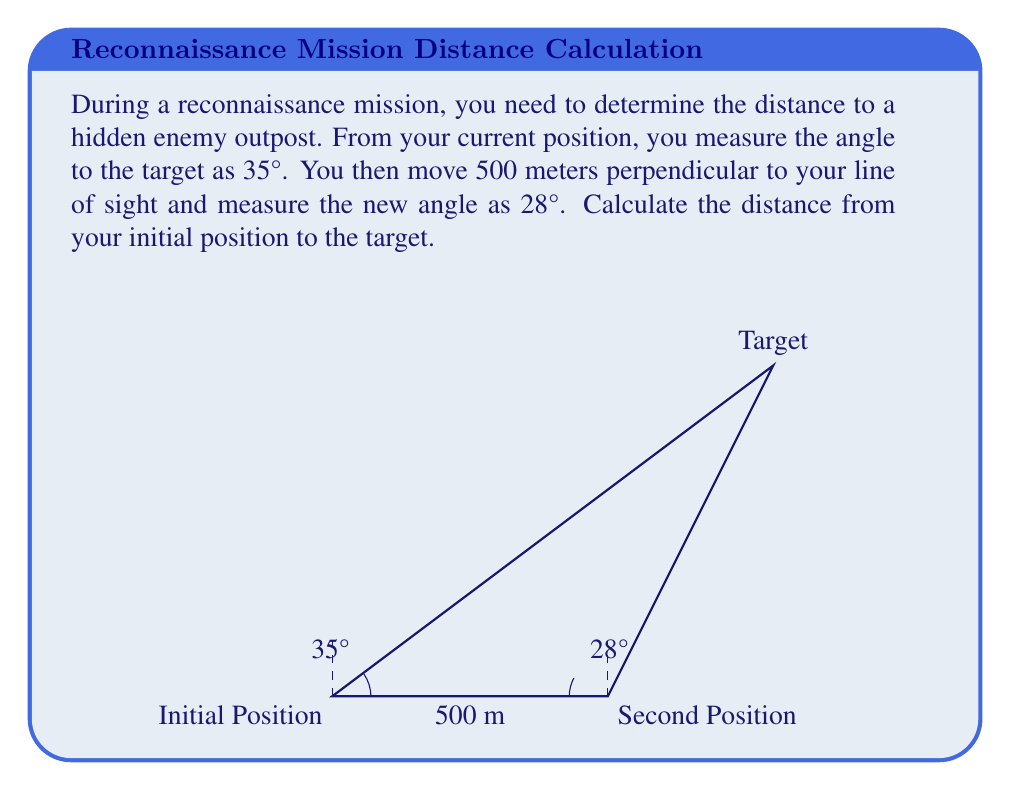What is the answer to this math problem? Let's solve this step-by-step using trigonometry:

1) First, we need to set up our triangle. Let's call the initial position A, the second position B, and the target C.

2) We know the distance AB = 500 meters, and the angles at A and B.

3) We can use the law of sines to solve this problem. The law of sines states:

   $$\frac{a}{\sin(A)} = \frac{b}{\sin(B)} = \frac{c}{\sin(C)}$$

   where a, b, and c are the lengths of the sides opposite to angles A, B, and C respectively.

4) In our case, we want to find AC (the distance to the target). Let's call this distance x. We know:
   - AB = 500 m
   - Angle at A = 35°
   - Angle at B = 28°

5) The angle at C is 180° - 35° - 28° = 117° (the sum of angles in a triangle is 180°)

6) Now we can set up our law of sines equation:

   $$\frac{x}{\sin(117°)} = \frac{500}{\sin(35°)}$$

7) Solving for x:

   $$x = \frac{500 \cdot \sin(117°)}{\sin(35°)}$$

8) Using a calculator (or trigonometric tables):

   $$x = \frac{500 \cdot 0.8910}{0.5736} \approx 777.02$$

Therefore, the distance from the initial position to the target is approximately 777 meters.
Answer: 777 meters 